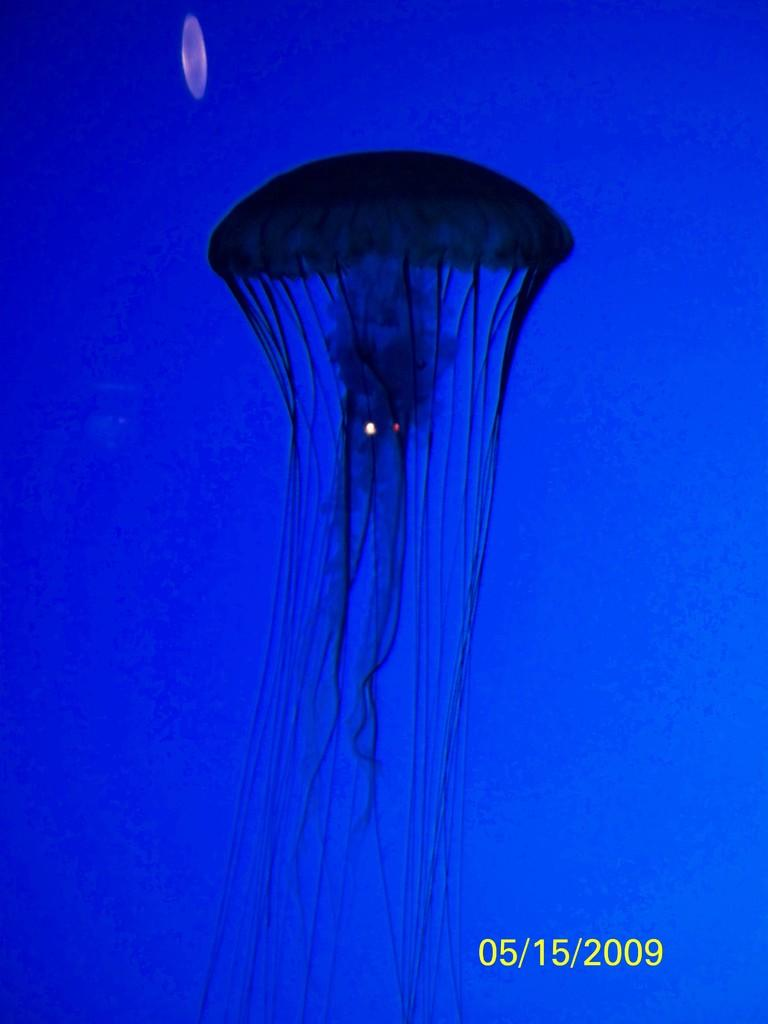What type of sea creatures are in the image? There are jellyfish in the image. What color is the background of the image? The background of the image is blue. Is there any text or information visible at the bottom of the image? Yes, the bottom of the image contains a date. What type of box is used for punishment in the image? There is no box or punishment present in the image; it features jellyfish in a blue background with a date at the bottom. 